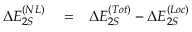<formula> <loc_0><loc_0><loc_500><loc_500>\begin{array} { r l r } { \Delta E _ { 2 S } ^ { ( N L ) } } & = } & { \Delta E _ { 2 S } ^ { ( T o t ) } - \Delta E _ { 2 S } ^ { ( L o c ) } } \end{array}</formula> 